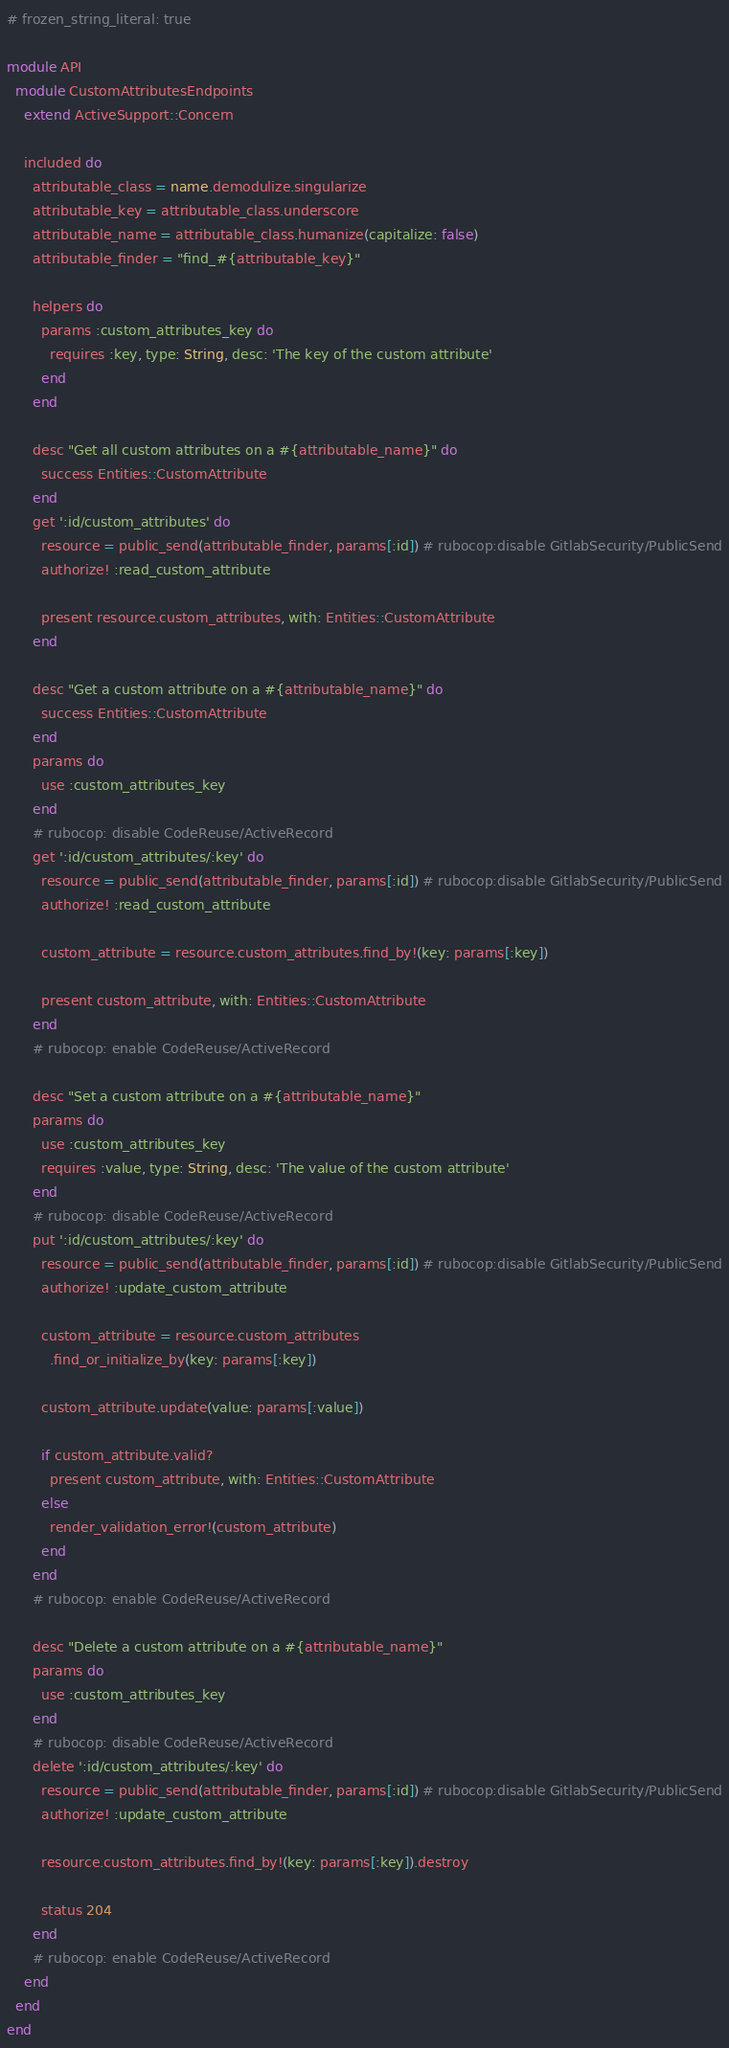Convert code to text. <code><loc_0><loc_0><loc_500><loc_500><_Ruby_># frozen_string_literal: true

module API
  module CustomAttributesEndpoints
    extend ActiveSupport::Concern

    included do
      attributable_class = name.demodulize.singularize
      attributable_key = attributable_class.underscore
      attributable_name = attributable_class.humanize(capitalize: false)
      attributable_finder = "find_#{attributable_key}"

      helpers do
        params :custom_attributes_key do
          requires :key, type: String, desc: 'The key of the custom attribute'
        end
      end

      desc "Get all custom attributes on a #{attributable_name}" do
        success Entities::CustomAttribute
      end
      get ':id/custom_attributes' do
        resource = public_send(attributable_finder, params[:id]) # rubocop:disable GitlabSecurity/PublicSend
        authorize! :read_custom_attribute

        present resource.custom_attributes, with: Entities::CustomAttribute
      end

      desc "Get a custom attribute on a #{attributable_name}" do
        success Entities::CustomAttribute
      end
      params do
        use :custom_attributes_key
      end
      # rubocop: disable CodeReuse/ActiveRecord
      get ':id/custom_attributes/:key' do
        resource = public_send(attributable_finder, params[:id]) # rubocop:disable GitlabSecurity/PublicSend
        authorize! :read_custom_attribute

        custom_attribute = resource.custom_attributes.find_by!(key: params[:key])

        present custom_attribute, with: Entities::CustomAttribute
      end
      # rubocop: enable CodeReuse/ActiveRecord

      desc "Set a custom attribute on a #{attributable_name}"
      params do
        use :custom_attributes_key
        requires :value, type: String, desc: 'The value of the custom attribute'
      end
      # rubocop: disable CodeReuse/ActiveRecord
      put ':id/custom_attributes/:key' do
        resource = public_send(attributable_finder, params[:id]) # rubocop:disable GitlabSecurity/PublicSend
        authorize! :update_custom_attribute

        custom_attribute = resource.custom_attributes
          .find_or_initialize_by(key: params[:key])

        custom_attribute.update(value: params[:value])

        if custom_attribute.valid?
          present custom_attribute, with: Entities::CustomAttribute
        else
          render_validation_error!(custom_attribute)
        end
      end
      # rubocop: enable CodeReuse/ActiveRecord

      desc "Delete a custom attribute on a #{attributable_name}"
      params do
        use :custom_attributes_key
      end
      # rubocop: disable CodeReuse/ActiveRecord
      delete ':id/custom_attributes/:key' do
        resource = public_send(attributable_finder, params[:id]) # rubocop:disable GitlabSecurity/PublicSend
        authorize! :update_custom_attribute

        resource.custom_attributes.find_by!(key: params[:key]).destroy

        status 204
      end
      # rubocop: enable CodeReuse/ActiveRecord
    end
  end
end
</code> 